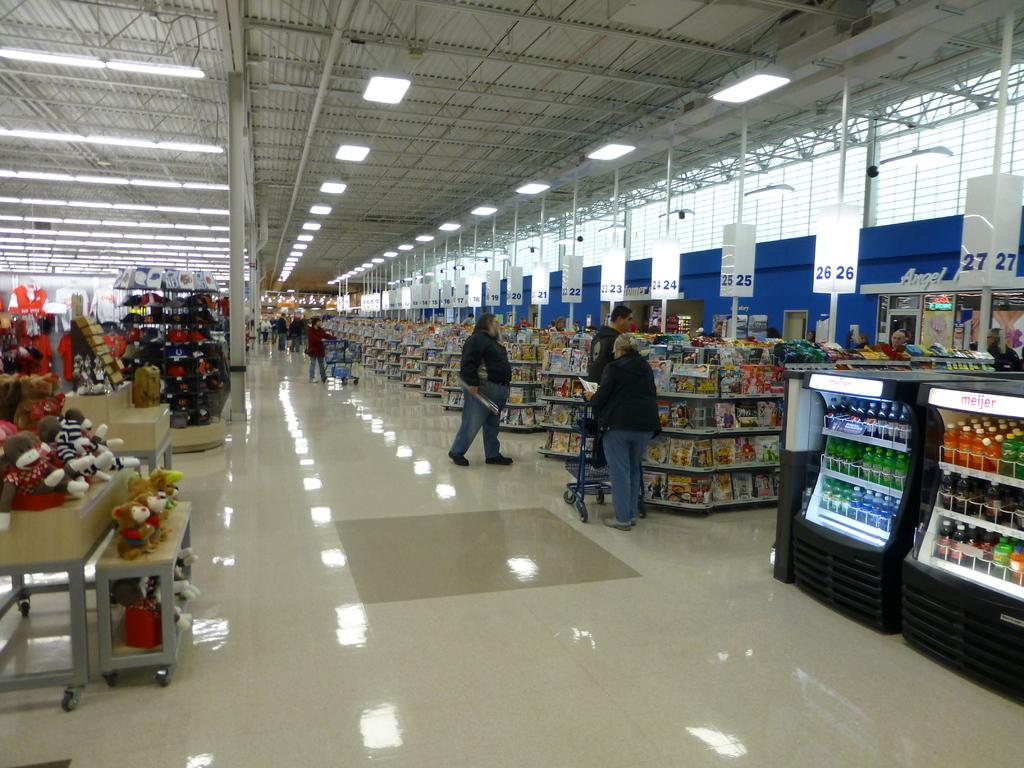<image>
Relay a brief, clear account of the picture shown. A few people mill about near the check out lines of a superstore with at least 27 check out lanes. 